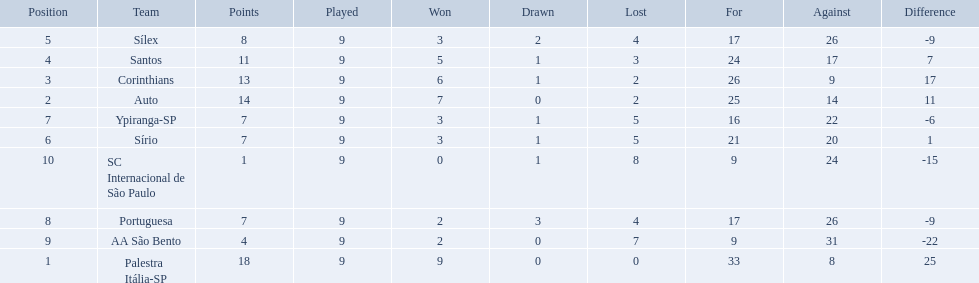What teams played in 1926? Palestra Itália-SP, Auto, Corinthians, Santos, Sílex, Sírio, Ypiranga-SP, Portuguesa, AA São Bento, SC Internacional de São Paulo. Did any team lose zero games? Palestra Itália-SP. 